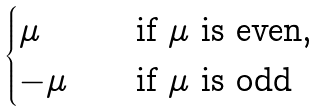Convert formula to latex. <formula><loc_0><loc_0><loc_500><loc_500>\begin{cases} \mu \quad & \text {if $\mu$ is even,} \\ - \mu \quad & \text {if $\mu$ is odd} \end{cases}</formula> 